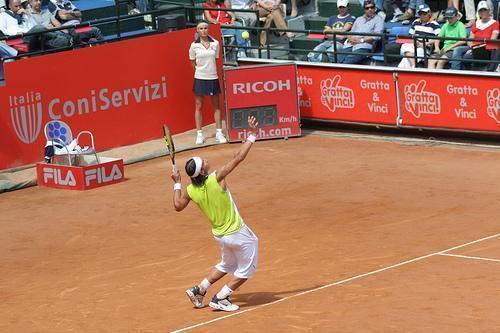Which hand caused the ball to go aloft here?
Choose the correct response, then elucidate: 'Answer: answer
Rationale: rationale.'
Options: Server's right, opposite player, none, left. Answer: server's right.
Rationale: The tennis player used his right hand to throw the ball up for the serve. 